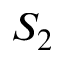<formula> <loc_0><loc_0><loc_500><loc_500>S _ { 2 }</formula> 